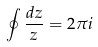<formula> <loc_0><loc_0><loc_500><loc_500>\oint \frac { d z } { z } = 2 \pi i</formula> 